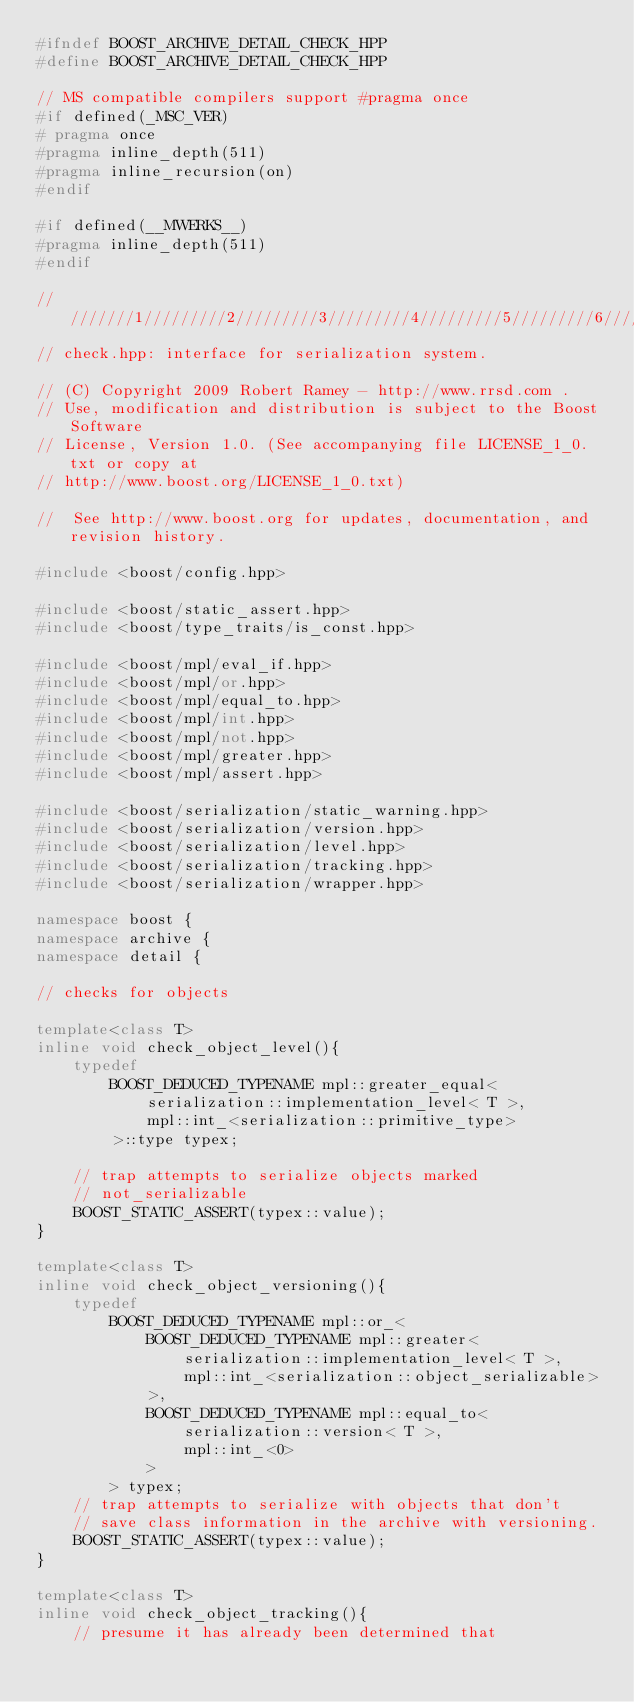Convert code to text. <code><loc_0><loc_0><loc_500><loc_500><_C++_>#ifndef BOOST_ARCHIVE_DETAIL_CHECK_HPP
#define BOOST_ARCHIVE_DETAIL_CHECK_HPP

// MS compatible compilers support #pragma once
#if defined(_MSC_VER)
# pragma once
#pragma inline_depth(511)
#pragma inline_recursion(on)
#endif

#if defined(__MWERKS__)
#pragma inline_depth(511)
#endif

/////////1/////////2/////////3/////////4/////////5/////////6/////////7/////////8
// check.hpp: interface for serialization system.

// (C) Copyright 2009 Robert Ramey - http://www.rrsd.com . 
// Use, modification and distribution is subject to the Boost Software
// License, Version 1.0. (See accompanying file LICENSE_1_0.txt or copy at
// http://www.boost.org/LICENSE_1_0.txt)

//  See http://www.boost.org for updates, documentation, and revision history.

#include <boost/config.hpp>

#include <boost/static_assert.hpp>
#include <boost/type_traits/is_const.hpp>

#include <boost/mpl/eval_if.hpp>
#include <boost/mpl/or.hpp>
#include <boost/mpl/equal_to.hpp>
#include <boost/mpl/int.hpp>
#include <boost/mpl/not.hpp>
#include <boost/mpl/greater.hpp>
#include <boost/mpl/assert.hpp>

#include <boost/serialization/static_warning.hpp>
#include <boost/serialization/version.hpp>
#include <boost/serialization/level.hpp>
#include <boost/serialization/tracking.hpp>
#include <boost/serialization/wrapper.hpp>

namespace boost {
namespace archive {
namespace detail {

// checks for objects

template<class T>
inline void check_object_level(){
    typedef 
        BOOST_DEDUCED_TYPENAME mpl::greater_equal<
            serialization::implementation_level< T >,
            mpl::int_<serialization::primitive_type>
        >::type typex;

    // trap attempts to serialize objects marked
    // not_serializable
    BOOST_STATIC_ASSERT(typex::value);
}

template<class T>
inline void check_object_versioning(){
    typedef 
        BOOST_DEDUCED_TYPENAME mpl::or_<
            BOOST_DEDUCED_TYPENAME mpl::greater<
                serialization::implementation_level< T >,
                mpl::int_<serialization::object_serializable>
            >,
            BOOST_DEDUCED_TYPENAME mpl::equal_to<
                serialization::version< T >,
                mpl::int_<0>
            >
        > typex;
    // trap attempts to serialize with objects that don't
    // save class information in the archive with versioning.
    BOOST_STATIC_ASSERT(typex::value);
}

template<class T>
inline void check_object_tracking(){
    // presume it has already been determined that</code> 